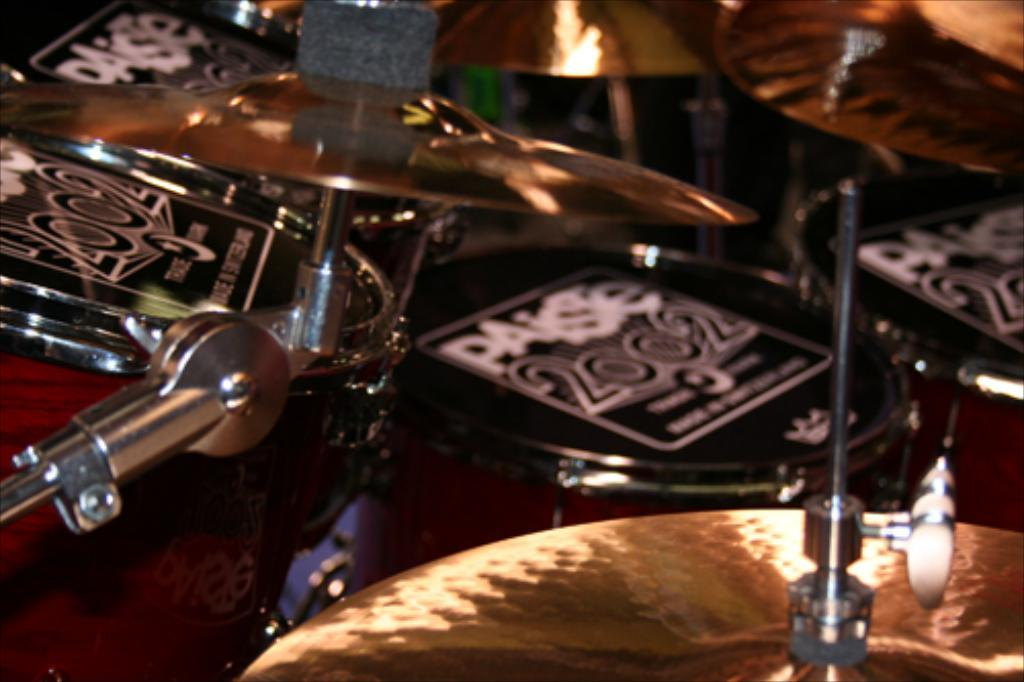What type of objects are present in the image? There are musical instruments in the image. What colors can be seen on the musical instruments? The musical instruments have black, red, and gold colors. How are the musical instruments arranged in the image? There are rows in the image, and the musical instruments are arranged in these rows. What color are the rows in the image? The rows have a silver color. What type of lace is used to decorate the cake in the image? There is no cake present in the image, so there is no lace to be used for decoration. What title is given to the musical instruments in the image? The image does not provide a title for the musical instruments. 